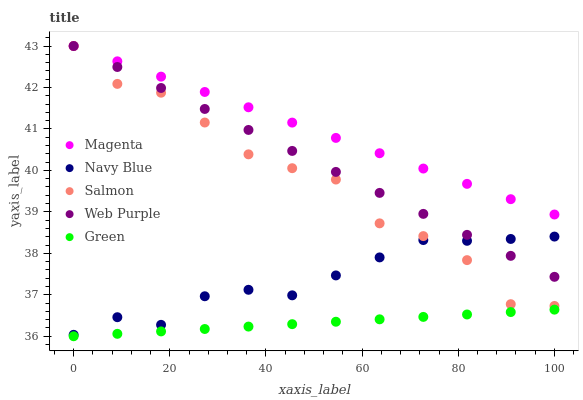Does Green have the minimum area under the curve?
Answer yes or no. Yes. Does Magenta have the maximum area under the curve?
Answer yes or no. Yes. Does Magenta have the minimum area under the curve?
Answer yes or no. No. Does Green have the maximum area under the curve?
Answer yes or no. No. Is Green the smoothest?
Answer yes or no. Yes. Is Salmon the roughest?
Answer yes or no. Yes. Is Magenta the smoothest?
Answer yes or no. No. Is Magenta the roughest?
Answer yes or no. No. Does Green have the lowest value?
Answer yes or no. Yes. Does Magenta have the lowest value?
Answer yes or no. No. Does Web Purple have the highest value?
Answer yes or no. Yes. Does Green have the highest value?
Answer yes or no. No. Is Green less than Salmon?
Answer yes or no. Yes. Is Navy Blue greater than Green?
Answer yes or no. Yes. Does Web Purple intersect Salmon?
Answer yes or no. Yes. Is Web Purple less than Salmon?
Answer yes or no. No. Is Web Purple greater than Salmon?
Answer yes or no. No. Does Green intersect Salmon?
Answer yes or no. No. 